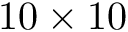Convert formula to latex. <formula><loc_0><loc_0><loc_500><loc_500>1 0 \times 1 0</formula> 